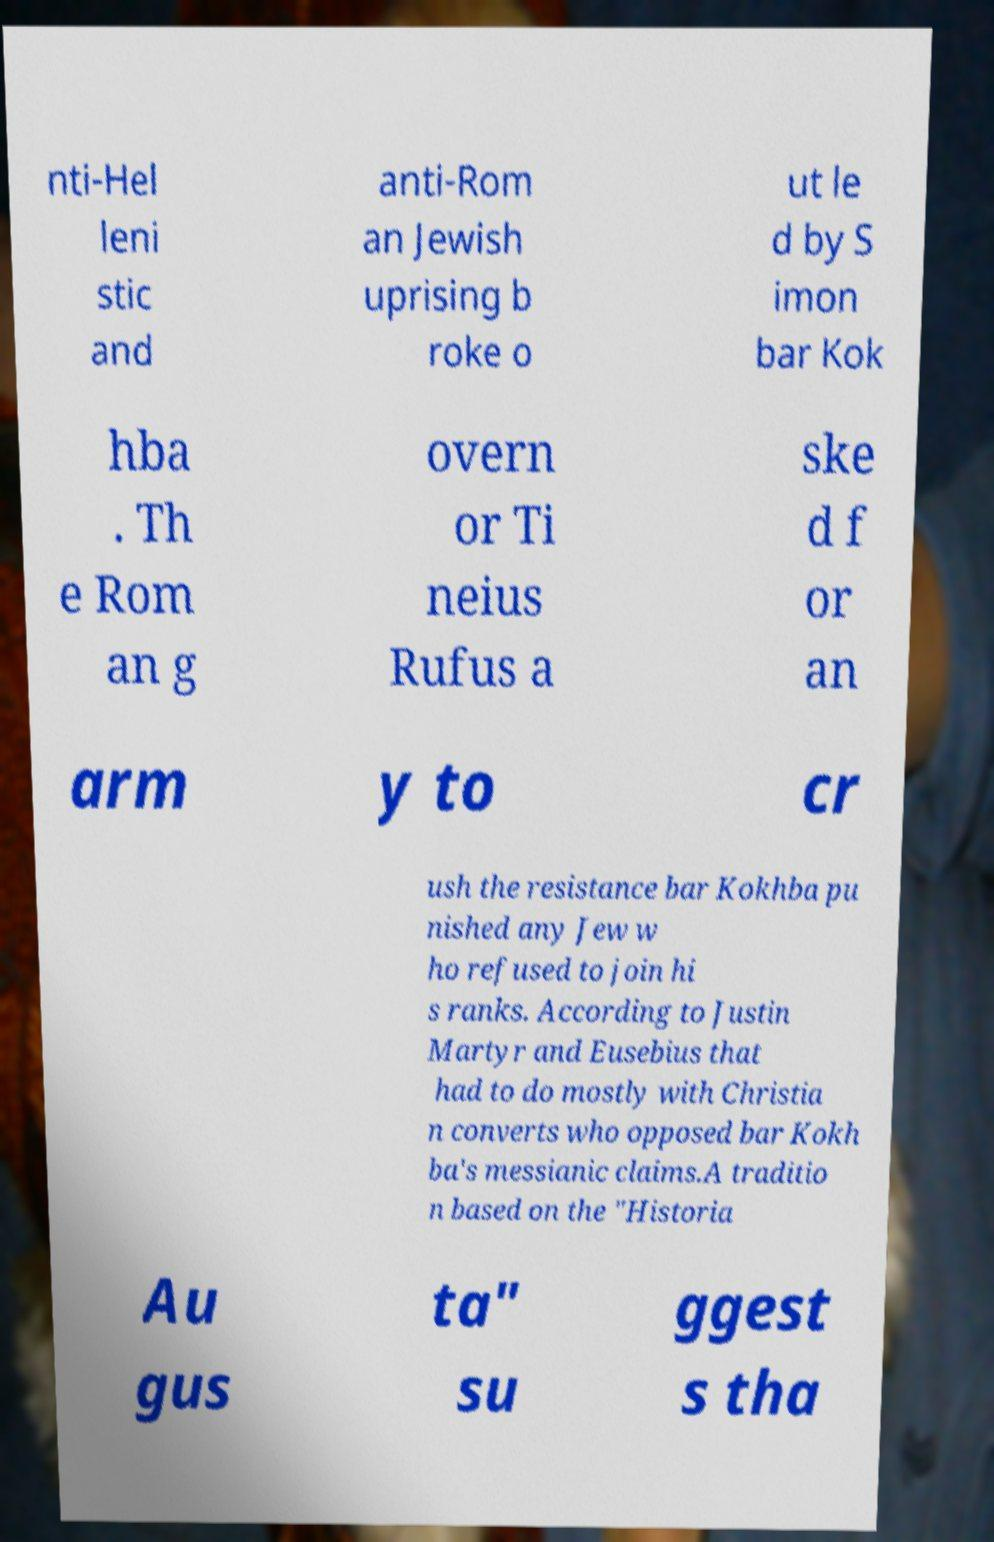Please identify and transcribe the text found in this image. nti-Hel leni stic and anti-Rom an Jewish uprising b roke o ut le d by S imon bar Kok hba . Th e Rom an g overn or Ti neius Rufus a ske d f or an arm y to cr ush the resistance bar Kokhba pu nished any Jew w ho refused to join hi s ranks. According to Justin Martyr and Eusebius that had to do mostly with Christia n converts who opposed bar Kokh ba's messianic claims.A traditio n based on the "Historia Au gus ta" su ggest s tha 